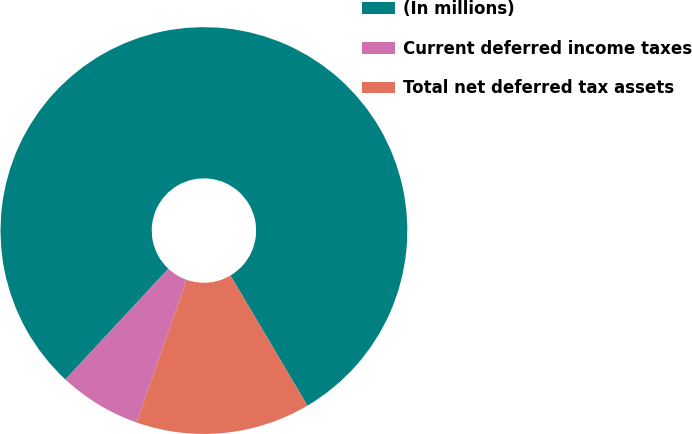Convert chart to OTSL. <chart><loc_0><loc_0><loc_500><loc_500><pie_chart><fcel>(In millions)<fcel>Current deferred income taxes<fcel>Total net deferred tax assets<nl><fcel>79.57%<fcel>6.56%<fcel>13.86%<nl></chart> 